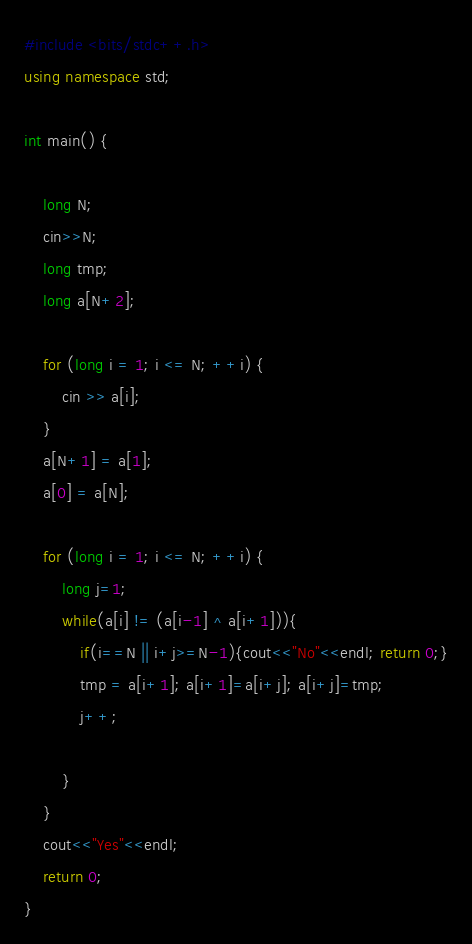Convert code to text. <code><loc_0><loc_0><loc_500><loc_500><_C++_>#include <bits/stdc++.h>
using namespace std;

int main() {

    long N;
    cin>>N;
    long tmp;
    long a[N+2];

    for (long i = 1; i <= N; ++i) {
        cin >> a[i];
    }
    a[N+1] = a[1];
    a[0] = a[N];

    for (long i = 1; i <= N; ++i) {
        long j=1;
        while(a[i] != (a[i-1] ^ a[i+1])){
            if(i==N || i+j>=N-1){cout<<"No"<<endl; return 0;}
            tmp = a[i+1]; a[i+1]=a[i+j]; a[i+j]=tmp;
            j++;

        }
    }
    cout<<"Yes"<<endl;
    return 0;
}</code> 